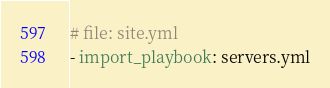<code> <loc_0><loc_0><loc_500><loc_500><_YAML_># file: site.yml
- import_playbook: servers.yml
</code> 